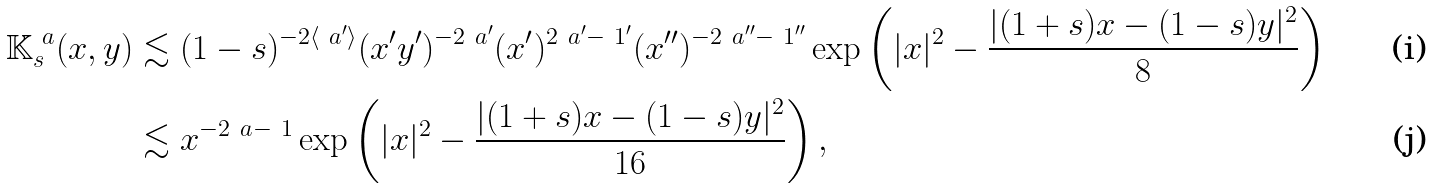Convert formula to latex. <formula><loc_0><loc_0><loc_500><loc_500>\mathbb { K } _ { s } ^ { \ a } ( x , y ) & \lesssim ( 1 - s ) ^ { - 2 \langle \ a ^ { \prime } \rangle } ( x ^ { \prime } y ^ { \prime } ) ^ { - 2 \ a ^ { \prime } } ( x ^ { \prime } ) ^ { 2 \ a ^ { \prime } - \ 1 ^ { \prime } } ( x ^ { \prime \prime } ) ^ { - 2 \ a ^ { \prime \prime } - \ 1 ^ { \prime \prime } } \exp \left ( | x | ^ { 2 } - \frac { | ( 1 + s ) x - ( 1 - s ) y | ^ { 2 } } { 8 } \right ) \\ & \lesssim x ^ { - 2 \ a - \ 1 } \exp \left ( | x | ^ { 2 } - \frac { | ( 1 + s ) x - ( 1 - s ) y | ^ { 2 } } { 1 6 } \right ) ,</formula> 